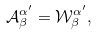<formula> <loc_0><loc_0><loc_500><loc_500>\mathcal { A } _ { \beta } ^ { \alpha ^ { \prime } } = \mathcal { W } _ { \beta } ^ { \alpha ^ { \prime } } ,</formula> 